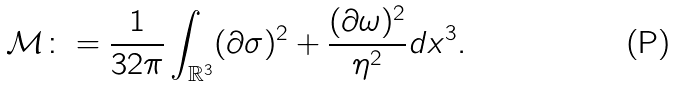Convert formula to latex. <formula><loc_0><loc_0><loc_500><loc_500>\mathcal { M } \colon = \frac { 1 } { 3 2 \pi } \int _ { \mathbb { R } ^ { 3 } } ( \partial \sigma ) ^ { 2 } + \frac { ( \partial \omega ) ^ { 2 } } { \eta ^ { 2 } } d x ^ { 3 } .</formula> 